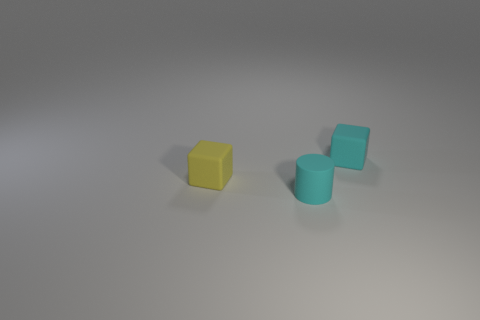Add 3 tiny yellow objects. How many objects exist? 6 Subtract all cyan blocks. How many blocks are left? 1 Subtract 2 cubes. How many cubes are left? 0 Subtract all blocks. How many objects are left? 1 Subtract all cyan cylinders. Subtract all purple matte objects. How many objects are left? 2 Add 1 cylinders. How many cylinders are left? 2 Add 1 green rubber cubes. How many green rubber cubes exist? 1 Subtract 0 purple cylinders. How many objects are left? 3 Subtract all yellow cylinders. Subtract all brown blocks. How many cylinders are left? 1 